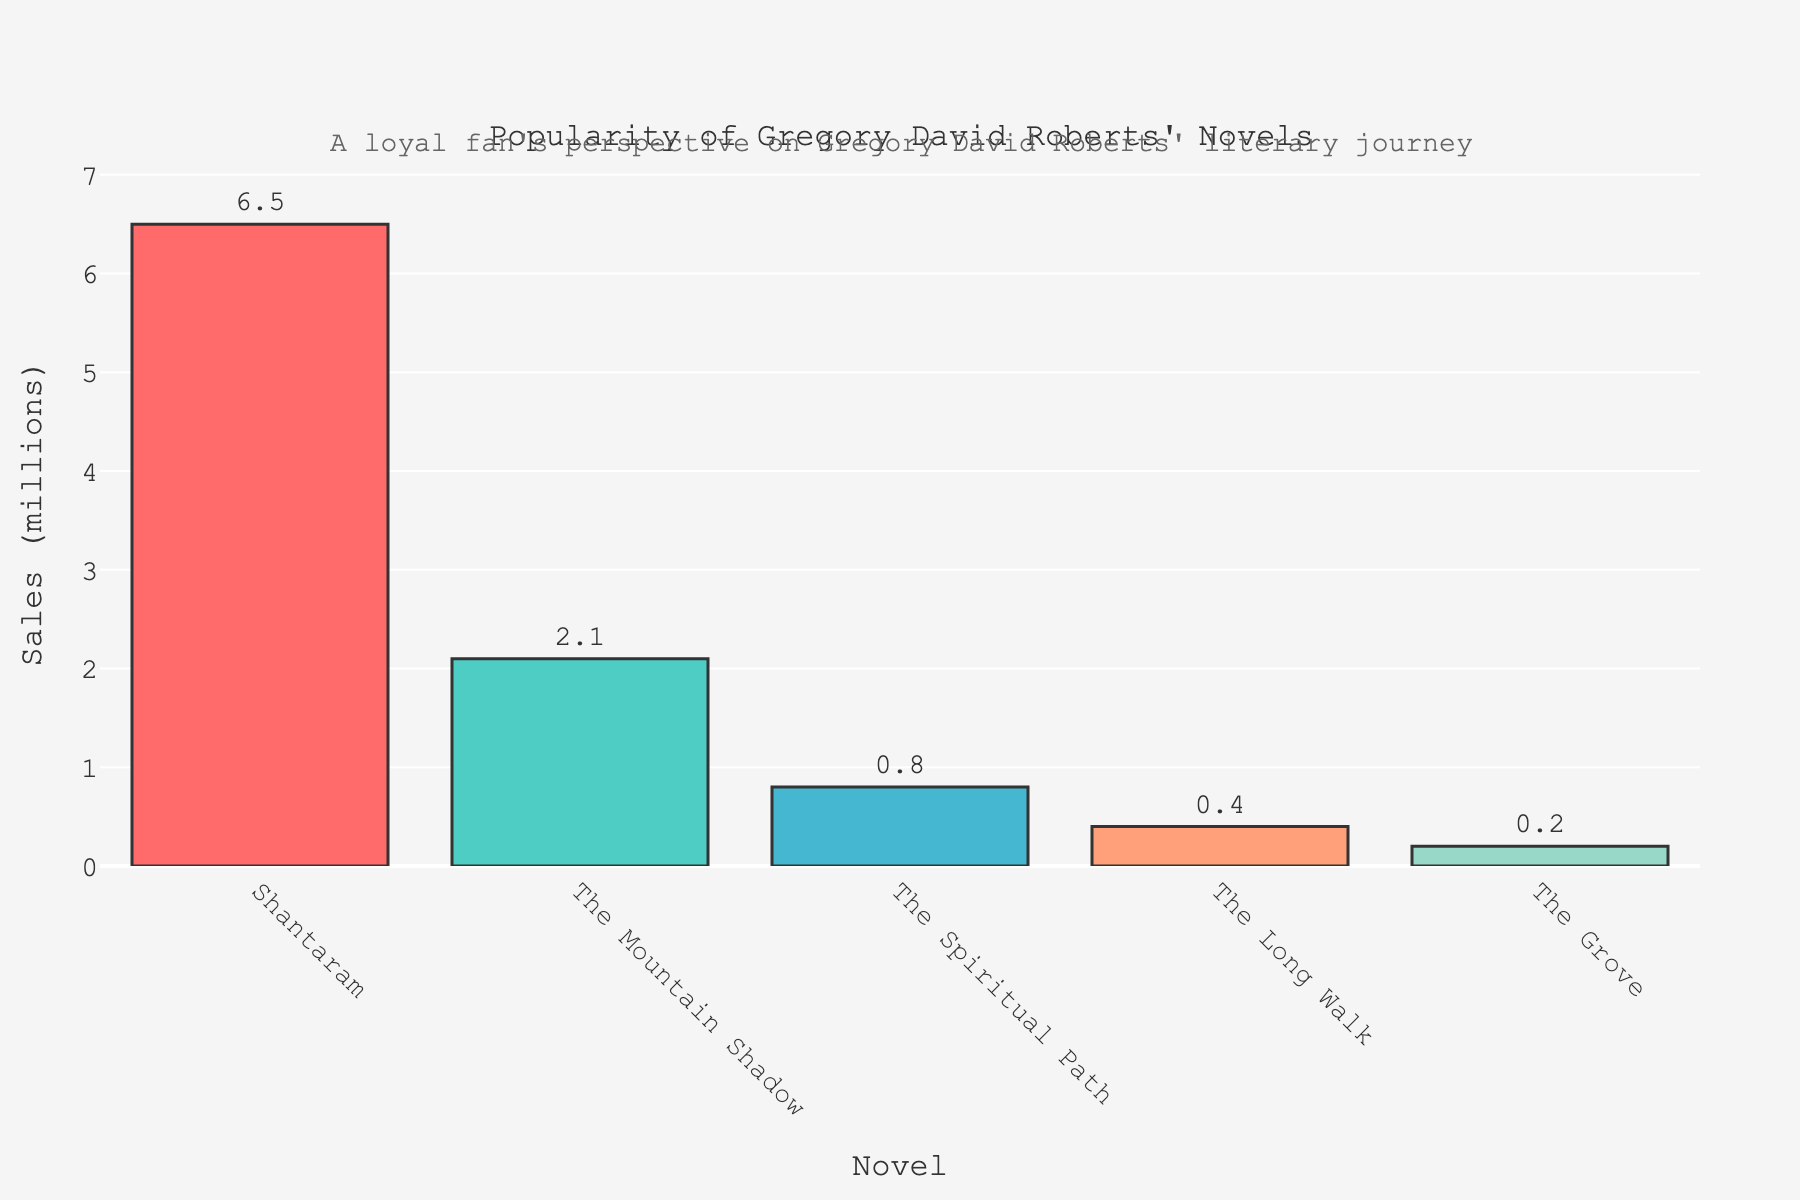What's the best-selling novel by Gregory David Roberts? The highest bar on the plot represents "Shantaram" with sales of 6.5 million copies, which is higher than all other novels on the chart.
Answer: Shantaram Which novel has the second highest sales after "Shantaram"? The second tallest bar represents "The Mountain Shadow," which has sales of 2.1 million copies. This is the second highest after "Shantaram."
Answer: The Mountain Shadow What is the combined sales of "The Long Walk" and "The Grove"? By summing the sales figures of "The Long Walk" (0.4 million) and "The Grove" (0.2 million), the total is 0.4 + 0.2 = 0.6 million copies.
Answer: 0.6 million How does the sales of "The Spiritual Path" compare to "The Long Walk"? "The Spiritual Path" has sales of 0.8 million copies, which is higher than "The Long Walk" with 0.4 million copies.
Answer: The Spiritual Path has more sales Which novel has the lowest sales figure, and how much is it? The shortest bar on the plot represents "The Grove" with sales of 0.2 million copies, making it the novel with the lowest sales.
Answer: The Grove, 0.2 million What is the difference in sales between "Shantaram" and "The Mountain Shadow"? "Shantaram" has sales of 6.5 million copies, and "The Mountain Shadow" has sales of 2.1 million copies. The difference in sales is 6.5 - 2.1 = 4.4 million copies.
Answer: 4.4 million If you combine the sales of "The Mountain Shadow" and "The Spiritual Path," how does it compare to "Shantaram"? "The Mountain Shadow" has sales of 2.1 million copies, and "The Spiritual Path" has sales of 0.8 million copies. Combined, they have sales of 2.1 + 0.8 = 2.9 million copies, which is less than the 6.5 million copies of "Shantaram."
Answer: Less than Shantaram What is the total sales figure for all the novels combined? By summing the sales of all novels: 6.5 + 2.1 + 0.8 + 0.4 + 0.2 = 10 million copies.
Answer: 10 million Which novel represented by a color other than red has the highest sales? Ignoring the red bar (Shantaram), the next highest sales are represented by "The Mountain Shadow" in green with 2.1 million copies.
Answer: The Mountain Shadow What's the average sales figure for the novels other than "Shantaram"? The sales figures for the other novels are: 2.1, 0.8, 0.4, and 0.2 million. Summing these values gives 2.1 + 0.8 + 0.4 + 0.2 = 3.5 million. The average is 3.5 / 4 = 0.875 million copies.
Answer: 0.875 million 